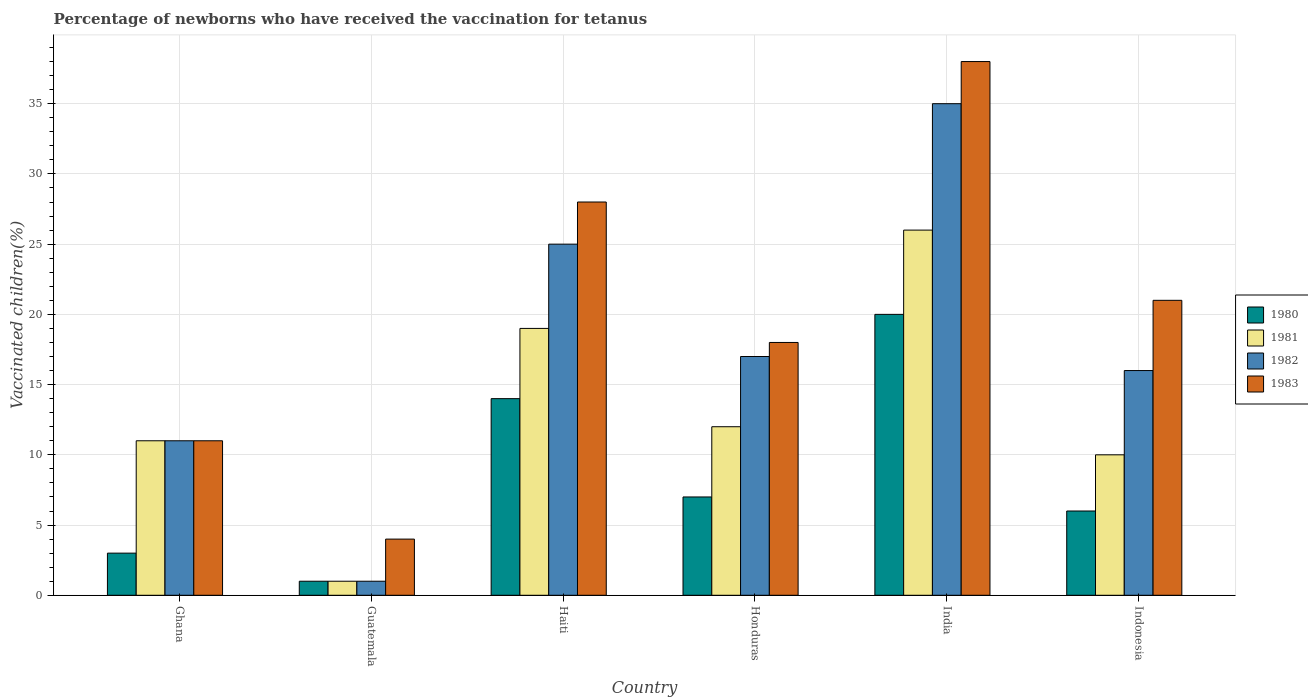How many different coloured bars are there?
Offer a terse response. 4. How many groups of bars are there?
Keep it short and to the point. 6. What is the percentage of vaccinated children in 1982 in Guatemala?
Provide a short and direct response. 1. In which country was the percentage of vaccinated children in 1981 minimum?
Your answer should be very brief. Guatemala. What is the total percentage of vaccinated children in 1981 in the graph?
Make the answer very short. 79. What is the difference between the percentage of vaccinated children in 1981 in Ghana and that in Indonesia?
Give a very brief answer. 1. What is the difference between the percentage of vaccinated children in 1980 in Indonesia and the percentage of vaccinated children in 1983 in Guatemala?
Keep it short and to the point. 2. What is the average percentage of vaccinated children in 1982 per country?
Keep it short and to the point. 17.5. What is the difference between the percentage of vaccinated children of/in 1981 and percentage of vaccinated children of/in 1983 in Ghana?
Keep it short and to the point. 0. What is the ratio of the percentage of vaccinated children in 1981 in Ghana to that in Guatemala?
Your response must be concise. 11. Is the percentage of vaccinated children in 1982 in Ghana less than that in Indonesia?
Keep it short and to the point. Yes. What is the difference between the highest and the lowest percentage of vaccinated children in 1980?
Offer a terse response. 19. In how many countries, is the percentage of vaccinated children in 1983 greater than the average percentage of vaccinated children in 1983 taken over all countries?
Your response must be concise. 3. Is it the case that in every country, the sum of the percentage of vaccinated children in 1982 and percentage of vaccinated children in 1980 is greater than the sum of percentage of vaccinated children in 1983 and percentage of vaccinated children in 1981?
Your response must be concise. No. What does the 4th bar from the left in India represents?
Your answer should be compact. 1983. How many bars are there?
Provide a succinct answer. 24. What is the difference between two consecutive major ticks on the Y-axis?
Offer a terse response. 5. Are the values on the major ticks of Y-axis written in scientific E-notation?
Ensure brevity in your answer.  No. Where does the legend appear in the graph?
Offer a very short reply. Center right. How are the legend labels stacked?
Ensure brevity in your answer.  Vertical. What is the title of the graph?
Provide a succinct answer. Percentage of newborns who have received the vaccination for tetanus. What is the label or title of the X-axis?
Offer a very short reply. Country. What is the label or title of the Y-axis?
Offer a terse response. Vaccinated children(%). What is the Vaccinated children(%) of 1983 in Ghana?
Your answer should be compact. 11. What is the Vaccinated children(%) in 1980 in Guatemala?
Your response must be concise. 1. What is the Vaccinated children(%) in 1981 in Guatemala?
Your answer should be compact. 1. What is the Vaccinated children(%) of 1983 in Guatemala?
Keep it short and to the point. 4. What is the Vaccinated children(%) of 1980 in Haiti?
Make the answer very short. 14. What is the Vaccinated children(%) of 1981 in Haiti?
Keep it short and to the point. 19. What is the Vaccinated children(%) of 1982 in Honduras?
Provide a succinct answer. 17. What is the Vaccinated children(%) of 1983 in Honduras?
Your answer should be very brief. 18. What is the Vaccinated children(%) of 1981 in India?
Provide a short and direct response. 26. What is the Vaccinated children(%) of 1982 in India?
Make the answer very short. 35. What is the Vaccinated children(%) in 1983 in Indonesia?
Provide a short and direct response. 21. Across all countries, what is the maximum Vaccinated children(%) in 1980?
Your answer should be very brief. 20. Across all countries, what is the maximum Vaccinated children(%) of 1982?
Keep it short and to the point. 35. Across all countries, what is the minimum Vaccinated children(%) of 1980?
Provide a short and direct response. 1. Across all countries, what is the minimum Vaccinated children(%) of 1982?
Provide a succinct answer. 1. Across all countries, what is the minimum Vaccinated children(%) of 1983?
Your answer should be compact. 4. What is the total Vaccinated children(%) of 1981 in the graph?
Provide a succinct answer. 79. What is the total Vaccinated children(%) of 1982 in the graph?
Make the answer very short. 105. What is the total Vaccinated children(%) in 1983 in the graph?
Your answer should be compact. 120. What is the difference between the Vaccinated children(%) of 1982 in Ghana and that in Guatemala?
Ensure brevity in your answer.  10. What is the difference between the Vaccinated children(%) of 1983 in Ghana and that in Guatemala?
Your answer should be very brief. 7. What is the difference between the Vaccinated children(%) in 1982 in Ghana and that in Haiti?
Provide a short and direct response. -14. What is the difference between the Vaccinated children(%) in 1981 in Ghana and that in Honduras?
Give a very brief answer. -1. What is the difference between the Vaccinated children(%) of 1983 in Ghana and that in Honduras?
Your answer should be very brief. -7. What is the difference between the Vaccinated children(%) of 1980 in Ghana and that in India?
Offer a terse response. -17. What is the difference between the Vaccinated children(%) of 1981 in Ghana and that in India?
Ensure brevity in your answer.  -15. What is the difference between the Vaccinated children(%) in 1982 in Ghana and that in India?
Offer a very short reply. -24. What is the difference between the Vaccinated children(%) in 1981 in Ghana and that in Indonesia?
Your answer should be very brief. 1. What is the difference between the Vaccinated children(%) in 1980 in Guatemala and that in Haiti?
Your response must be concise. -13. What is the difference between the Vaccinated children(%) of 1981 in Guatemala and that in Haiti?
Your response must be concise. -18. What is the difference between the Vaccinated children(%) in 1982 in Guatemala and that in Haiti?
Your answer should be very brief. -24. What is the difference between the Vaccinated children(%) of 1983 in Guatemala and that in Haiti?
Provide a short and direct response. -24. What is the difference between the Vaccinated children(%) in 1981 in Guatemala and that in Honduras?
Offer a very short reply. -11. What is the difference between the Vaccinated children(%) of 1983 in Guatemala and that in Honduras?
Your response must be concise. -14. What is the difference between the Vaccinated children(%) in 1980 in Guatemala and that in India?
Ensure brevity in your answer.  -19. What is the difference between the Vaccinated children(%) of 1981 in Guatemala and that in India?
Your answer should be compact. -25. What is the difference between the Vaccinated children(%) in 1982 in Guatemala and that in India?
Your answer should be very brief. -34. What is the difference between the Vaccinated children(%) in 1983 in Guatemala and that in India?
Make the answer very short. -34. What is the difference between the Vaccinated children(%) in 1981 in Guatemala and that in Indonesia?
Your answer should be very brief. -9. What is the difference between the Vaccinated children(%) in 1982 in Haiti and that in Honduras?
Offer a terse response. 8. What is the difference between the Vaccinated children(%) in 1983 in Haiti and that in Honduras?
Make the answer very short. 10. What is the difference between the Vaccinated children(%) in 1980 in Haiti and that in India?
Your response must be concise. -6. What is the difference between the Vaccinated children(%) of 1980 in Haiti and that in Indonesia?
Your answer should be compact. 8. What is the difference between the Vaccinated children(%) in 1981 in Haiti and that in Indonesia?
Offer a very short reply. 9. What is the difference between the Vaccinated children(%) of 1983 in Haiti and that in Indonesia?
Offer a very short reply. 7. What is the difference between the Vaccinated children(%) of 1981 in Honduras and that in India?
Provide a succinct answer. -14. What is the difference between the Vaccinated children(%) of 1982 in Honduras and that in India?
Your response must be concise. -18. What is the difference between the Vaccinated children(%) of 1980 in Honduras and that in Indonesia?
Offer a very short reply. 1. What is the difference between the Vaccinated children(%) in 1981 in Honduras and that in Indonesia?
Provide a succinct answer. 2. What is the difference between the Vaccinated children(%) of 1983 in India and that in Indonesia?
Ensure brevity in your answer.  17. What is the difference between the Vaccinated children(%) of 1980 in Ghana and the Vaccinated children(%) of 1982 in Guatemala?
Offer a terse response. 2. What is the difference between the Vaccinated children(%) of 1980 in Ghana and the Vaccinated children(%) of 1983 in Haiti?
Give a very brief answer. -25. What is the difference between the Vaccinated children(%) in 1980 in Ghana and the Vaccinated children(%) in 1981 in Honduras?
Offer a terse response. -9. What is the difference between the Vaccinated children(%) of 1982 in Ghana and the Vaccinated children(%) of 1983 in Honduras?
Ensure brevity in your answer.  -7. What is the difference between the Vaccinated children(%) of 1980 in Ghana and the Vaccinated children(%) of 1982 in India?
Provide a short and direct response. -32. What is the difference between the Vaccinated children(%) of 1980 in Ghana and the Vaccinated children(%) of 1983 in India?
Ensure brevity in your answer.  -35. What is the difference between the Vaccinated children(%) in 1980 in Ghana and the Vaccinated children(%) in 1982 in Indonesia?
Offer a terse response. -13. What is the difference between the Vaccinated children(%) in 1981 in Ghana and the Vaccinated children(%) in 1982 in Indonesia?
Keep it short and to the point. -5. What is the difference between the Vaccinated children(%) in 1981 in Ghana and the Vaccinated children(%) in 1983 in Indonesia?
Provide a succinct answer. -10. What is the difference between the Vaccinated children(%) of 1980 in Guatemala and the Vaccinated children(%) of 1981 in Haiti?
Make the answer very short. -18. What is the difference between the Vaccinated children(%) of 1981 in Guatemala and the Vaccinated children(%) of 1983 in Haiti?
Ensure brevity in your answer.  -27. What is the difference between the Vaccinated children(%) of 1982 in Guatemala and the Vaccinated children(%) of 1983 in Haiti?
Offer a terse response. -27. What is the difference between the Vaccinated children(%) of 1980 in Guatemala and the Vaccinated children(%) of 1981 in Honduras?
Ensure brevity in your answer.  -11. What is the difference between the Vaccinated children(%) of 1980 in Guatemala and the Vaccinated children(%) of 1982 in Honduras?
Provide a short and direct response. -16. What is the difference between the Vaccinated children(%) in 1980 in Guatemala and the Vaccinated children(%) in 1983 in Honduras?
Your response must be concise. -17. What is the difference between the Vaccinated children(%) of 1981 in Guatemala and the Vaccinated children(%) of 1982 in Honduras?
Provide a succinct answer. -16. What is the difference between the Vaccinated children(%) of 1980 in Guatemala and the Vaccinated children(%) of 1982 in India?
Your response must be concise. -34. What is the difference between the Vaccinated children(%) of 1980 in Guatemala and the Vaccinated children(%) of 1983 in India?
Your answer should be compact. -37. What is the difference between the Vaccinated children(%) of 1981 in Guatemala and the Vaccinated children(%) of 1982 in India?
Your response must be concise. -34. What is the difference between the Vaccinated children(%) in 1981 in Guatemala and the Vaccinated children(%) in 1983 in India?
Provide a short and direct response. -37. What is the difference between the Vaccinated children(%) of 1982 in Guatemala and the Vaccinated children(%) of 1983 in India?
Provide a succinct answer. -37. What is the difference between the Vaccinated children(%) in 1980 in Guatemala and the Vaccinated children(%) in 1982 in Indonesia?
Your answer should be compact. -15. What is the difference between the Vaccinated children(%) in 1981 in Guatemala and the Vaccinated children(%) in 1982 in Indonesia?
Your answer should be very brief. -15. What is the difference between the Vaccinated children(%) in 1980 in Haiti and the Vaccinated children(%) in 1982 in Honduras?
Give a very brief answer. -3. What is the difference between the Vaccinated children(%) of 1980 in Haiti and the Vaccinated children(%) of 1983 in Honduras?
Offer a terse response. -4. What is the difference between the Vaccinated children(%) of 1982 in Haiti and the Vaccinated children(%) of 1983 in Honduras?
Provide a succinct answer. 7. What is the difference between the Vaccinated children(%) in 1980 in Haiti and the Vaccinated children(%) in 1982 in India?
Make the answer very short. -21. What is the difference between the Vaccinated children(%) in 1981 in Haiti and the Vaccinated children(%) in 1982 in India?
Your answer should be very brief. -16. What is the difference between the Vaccinated children(%) of 1981 in Haiti and the Vaccinated children(%) of 1983 in India?
Provide a short and direct response. -19. What is the difference between the Vaccinated children(%) in 1980 in Haiti and the Vaccinated children(%) in 1982 in Indonesia?
Offer a very short reply. -2. What is the difference between the Vaccinated children(%) of 1982 in Haiti and the Vaccinated children(%) of 1983 in Indonesia?
Offer a terse response. 4. What is the difference between the Vaccinated children(%) in 1980 in Honduras and the Vaccinated children(%) in 1981 in India?
Your answer should be compact. -19. What is the difference between the Vaccinated children(%) in 1980 in Honduras and the Vaccinated children(%) in 1982 in India?
Give a very brief answer. -28. What is the difference between the Vaccinated children(%) in 1980 in Honduras and the Vaccinated children(%) in 1983 in India?
Offer a terse response. -31. What is the difference between the Vaccinated children(%) in 1981 in Honduras and the Vaccinated children(%) in 1982 in India?
Provide a succinct answer. -23. What is the difference between the Vaccinated children(%) of 1981 in Honduras and the Vaccinated children(%) of 1983 in India?
Give a very brief answer. -26. What is the difference between the Vaccinated children(%) of 1980 in Honduras and the Vaccinated children(%) of 1982 in Indonesia?
Keep it short and to the point. -9. What is the difference between the Vaccinated children(%) of 1982 in Honduras and the Vaccinated children(%) of 1983 in Indonesia?
Your response must be concise. -4. What is the difference between the Vaccinated children(%) in 1980 in India and the Vaccinated children(%) in 1981 in Indonesia?
Provide a short and direct response. 10. What is the difference between the Vaccinated children(%) of 1982 in India and the Vaccinated children(%) of 1983 in Indonesia?
Provide a succinct answer. 14. What is the average Vaccinated children(%) of 1980 per country?
Make the answer very short. 8.5. What is the average Vaccinated children(%) of 1981 per country?
Keep it short and to the point. 13.17. What is the difference between the Vaccinated children(%) of 1980 and Vaccinated children(%) of 1982 in Ghana?
Give a very brief answer. -8. What is the difference between the Vaccinated children(%) of 1980 and Vaccinated children(%) of 1983 in Ghana?
Your answer should be compact. -8. What is the difference between the Vaccinated children(%) in 1982 and Vaccinated children(%) in 1983 in Ghana?
Provide a succinct answer. 0. What is the difference between the Vaccinated children(%) of 1980 and Vaccinated children(%) of 1981 in Guatemala?
Provide a short and direct response. 0. What is the difference between the Vaccinated children(%) of 1980 and Vaccinated children(%) of 1983 in Guatemala?
Keep it short and to the point. -3. What is the difference between the Vaccinated children(%) of 1981 and Vaccinated children(%) of 1982 in Guatemala?
Offer a very short reply. 0. What is the difference between the Vaccinated children(%) in 1982 and Vaccinated children(%) in 1983 in Guatemala?
Your response must be concise. -3. What is the difference between the Vaccinated children(%) of 1980 and Vaccinated children(%) of 1983 in Haiti?
Provide a succinct answer. -14. What is the difference between the Vaccinated children(%) in 1981 and Vaccinated children(%) in 1983 in Haiti?
Your answer should be very brief. -9. What is the difference between the Vaccinated children(%) of 1982 and Vaccinated children(%) of 1983 in Haiti?
Give a very brief answer. -3. What is the difference between the Vaccinated children(%) of 1980 and Vaccinated children(%) of 1981 in Honduras?
Offer a very short reply. -5. What is the difference between the Vaccinated children(%) in 1980 and Vaccinated children(%) in 1983 in Honduras?
Your response must be concise. -11. What is the difference between the Vaccinated children(%) of 1981 and Vaccinated children(%) of 1982 in Honduras?
Keep it short and to the point. -5. What is the difference between the Vaccinated children(%) of 1980 and Vaccinated children(%) of 1981 in India?
Give a very brief answer. -6. What is the difference between the Vaccinated children(%) of 1980 and Vaccinated children(%) of 1983 in India?
Ensure brevity in your answer.  -18. What is the difference between the Vaccinated children(%) in 1981 and Vaccinated children(%) in 1982 in India?
Provide a succinct answer. -9. What is the difference between the Vaccinated children(%) in 1981 and Vaccinated children(%) in 1982 in Indonesia?
Your response must be concise. -6. What is the difference between the Vaccinated children(%) in 1981 and Vaccinated children(%) in 1983 in Indonesia?
Make the answer very short. -11. What is the difference between the Vaccinated children(%) of 1982 and Vaccinated children(%) of 1983 in Indonesia?
Offer a terse response. -5. What is the ratio of the Vaccinated children(%) of 1980 in Ghana to that in Guatemala?
Provide a succinct answer. 3. What is the ratio of the Vaccinated children(%) of 1981 in Ghana to that in Guatemala?
Make the answer very short. 11. What is the ratio of the Vaccinated children(%) of 1983 in Ghana to that in Guatemala?
Offer a terse response. 2.75. What is the ratio of the Vaccinated children(%) of 1980 in Ghana to that in Haiti?
Give a very brief answer. 0.21. What is the ratio of the Vaccinated children(%) of 1981 in Ghana to that in Haiti?
Ensure brevity in your answer.  0.58. What is the ratio of the Vaccinated children(%) in 1982 in Ghana to that in Haiti?
Provide a short and direct response. 0.44. What is the ratio of the Vaccinated children(%) in 1983 in Ghana to that in Haiti?
Give a very brief answer. 0.39. What is the ratio of the Vaccinated children(%) in 1980 in Ghana to that in Honduras?
Your answer should be compact. 0.43. What is the ratio of the Vaccinated children(%) in 1982 in Ghana to that in Honduras?
Keep it short and to the point. 0.65. What is the ratio of the Vaccinated children(%) of 1983 in Ghana to that in Honduras?
Offer a very short reply. 0.61. What is the ratio of the Vaccinated children(%) of 1981 in Ghana to that in India?
Provide a short and direct response. 0.42. What is the ratio of the Vaccinated children(%) in 1982 in Ghana to that in India?
Your response must be concise. 0.31. What is the ratio of the Vaccinated children(%) of 1983 in Ghana to that in India?
Provide a short and direct response. 0.29. What is the ratio of the Vaccinated children(%) in 1982 in Ghana to that in Indonesia?
Offer a very short reply. 0.69. What is the ratio of the Vaccinated children(%) in 1983 in Ghana to that in Indonesia?
Your answer should be very brief. 0.52. What is the ratio of the Vaccinated children(%) of 1980 in Guatemala to that in Haiti?
Your answer should be compact. 0.07. What is the ratio of the Vaccinated children(%) of 1981 in Guatemala to that in Haiti?
Ensure brevity in your answer.  0.05. What is the ratio of the Vaccinated children(%) in 1982 in Guatemala to that in Haiti?
Offer a terse response. 0.04. What is the ratio of the Vaccinated children(%) in 1983 in Guatemala to that in Haiti?
Give a very brief answer. 0.14. What is the ratio of the Vaccinated children(%) in 1980 in Guatemala to that in Honduras?
Provide a short and direct response. 0.14. What is the ratio of the Vaccinated children(%) in 1981 in Guatemala to that in Honduras?
Your response must be concise. 0.08. What is the ratio of the Vaccinated children(%) in 1982 in Guatemala to that in Honduras?
Keep it short and to the point. 0.06. What is the ratio of the Vaccinated children(%) of 1983 in Guatemala to that in Honduras?
Your response must be concise. 0.22. What is the ratio of the Vaccinated children(%) of 1980 in Guatemala to that in India?
Provide a short and direct response. 0.05. What is the ratio of the Vaccinated children(%) in 1981 in Guatemala to that in India?
Your response must be concise. 0.04. What is the ratio of the Vaccinated children(%) in 1982 in Guatemala to that in India?
Give a very brief answer. 0.03. What is the ratio of the Vaccinated children(%) of 1983 in Guatemala to that in India?
Offer a very short reply. 0.11. What is the ratio of the Vaccinated children(%) of 1980 in Guatemala to that in Indonesia?
Your response must be concise. 0.17. What is the ratio of the Vaccinated children(%) of 1981 in Guatemala to that in Indonesia?
Provide a short and direct response. 0.1. What is the ratio of the Vaccinated children(%) in 1982 in Guatemala to that in Indonesia?
Provide a succinct answer. 0.06. What is the ratio of the Vaccinated children(%) in 1983 in Guatemala to that in Indonesia?
Your answer should be very brief. 0.19. What is the ratio of the Vaccinated children(%) of 1980 in Haiti to that in Honduras?
Make the answer very short. 2. What is the ratio of the Vaccinated children(%) of 1981 in Haiti to that in Honduras?
Give a very brief answer. 1.58. What is the ratio of the Vaccinated children(%) of 1982 in Haiti to that in Honduras?
Provide a succinct answer. 1.47. What is the ratio of the Vaccinated children(%) of 1983 in Haiti to that in Honduras?
Ensure brevity in your answer.  1.56. What is the ratio of the Vaccinated children(%) of 1981 in Haiti to that in India?
Your answer should be very brief. 0.73. What is the ratio of the Vaccinated children(%) of 1983 in Haiti to that in India?
Your answer should be very brief. 0.74. What is the ratio of the Vaccinated children(%) in 1980 in Haiti to that in Indonesia?
Provide a succinct answer. 2.33. What is the ratio of the Vaccinated children(%) of 1981 in Haiti to that in Indonesia?
Provide a short and direct response. 1.9. What is the ratio of the Vaccinated children(%) in 1982 in Haiti to that in Indonesia?
Your answer should be very brief. 1.56. What is the ratio of the Vaccinated children(%) of 1980 in Honduras to that in India?
Give a very brief answer. 0.35. What is the ratio of the Vaccinated children(%) in 1981 in Honduras to that in India?
Offer a very short reply. 0.46. What is the ratio of the Vaccinated children(%) of 1982 in Honduras to that in India?
Provide a short and direct response. 0.49. What is the ratio of the Vaccinated children(%) of 1983 in Honduras to that in India?
Give a very brief answer. 0.47. What is the ratio of the Vaccinated children(%) of 1981 in Honduras to that in Indonesia?
Offer a very short reply. 1.2. What is the ratio of the Vaccinated children(%) of 1982 in Honduras to that in Indonesia?
Your response must be concise. 1.06. What is the ratio of the Vaccinated children(%) of 1980 in India to that in Indonesia?
Offer a very short reply. 3.33. What is the ratio of the Vaccinated children(%) of 1982 in India to that in Indonesia?
Give a very brief answer. 2.19. What is the ratio of the Vaccinated children(%) of 1983 in India to that in Indonesia?
Give a very brief answer. 1.81. What is the difference between the highest and the second highest Vaccinated children(%) of 1983?
Keep it short and to the point. 10. What is the difference between the highest and the lowest Vaccinated children(%) in 1980?
Provide a succinct answer. 19. What is the difference between the highest and the lowest Vaccinated children(%) in 1981?
Make the answer very short. 25. What is the difference between the highest and the lowest Vaccinated children(%) in 1982?
Ensure brevity in your answer.  34. 